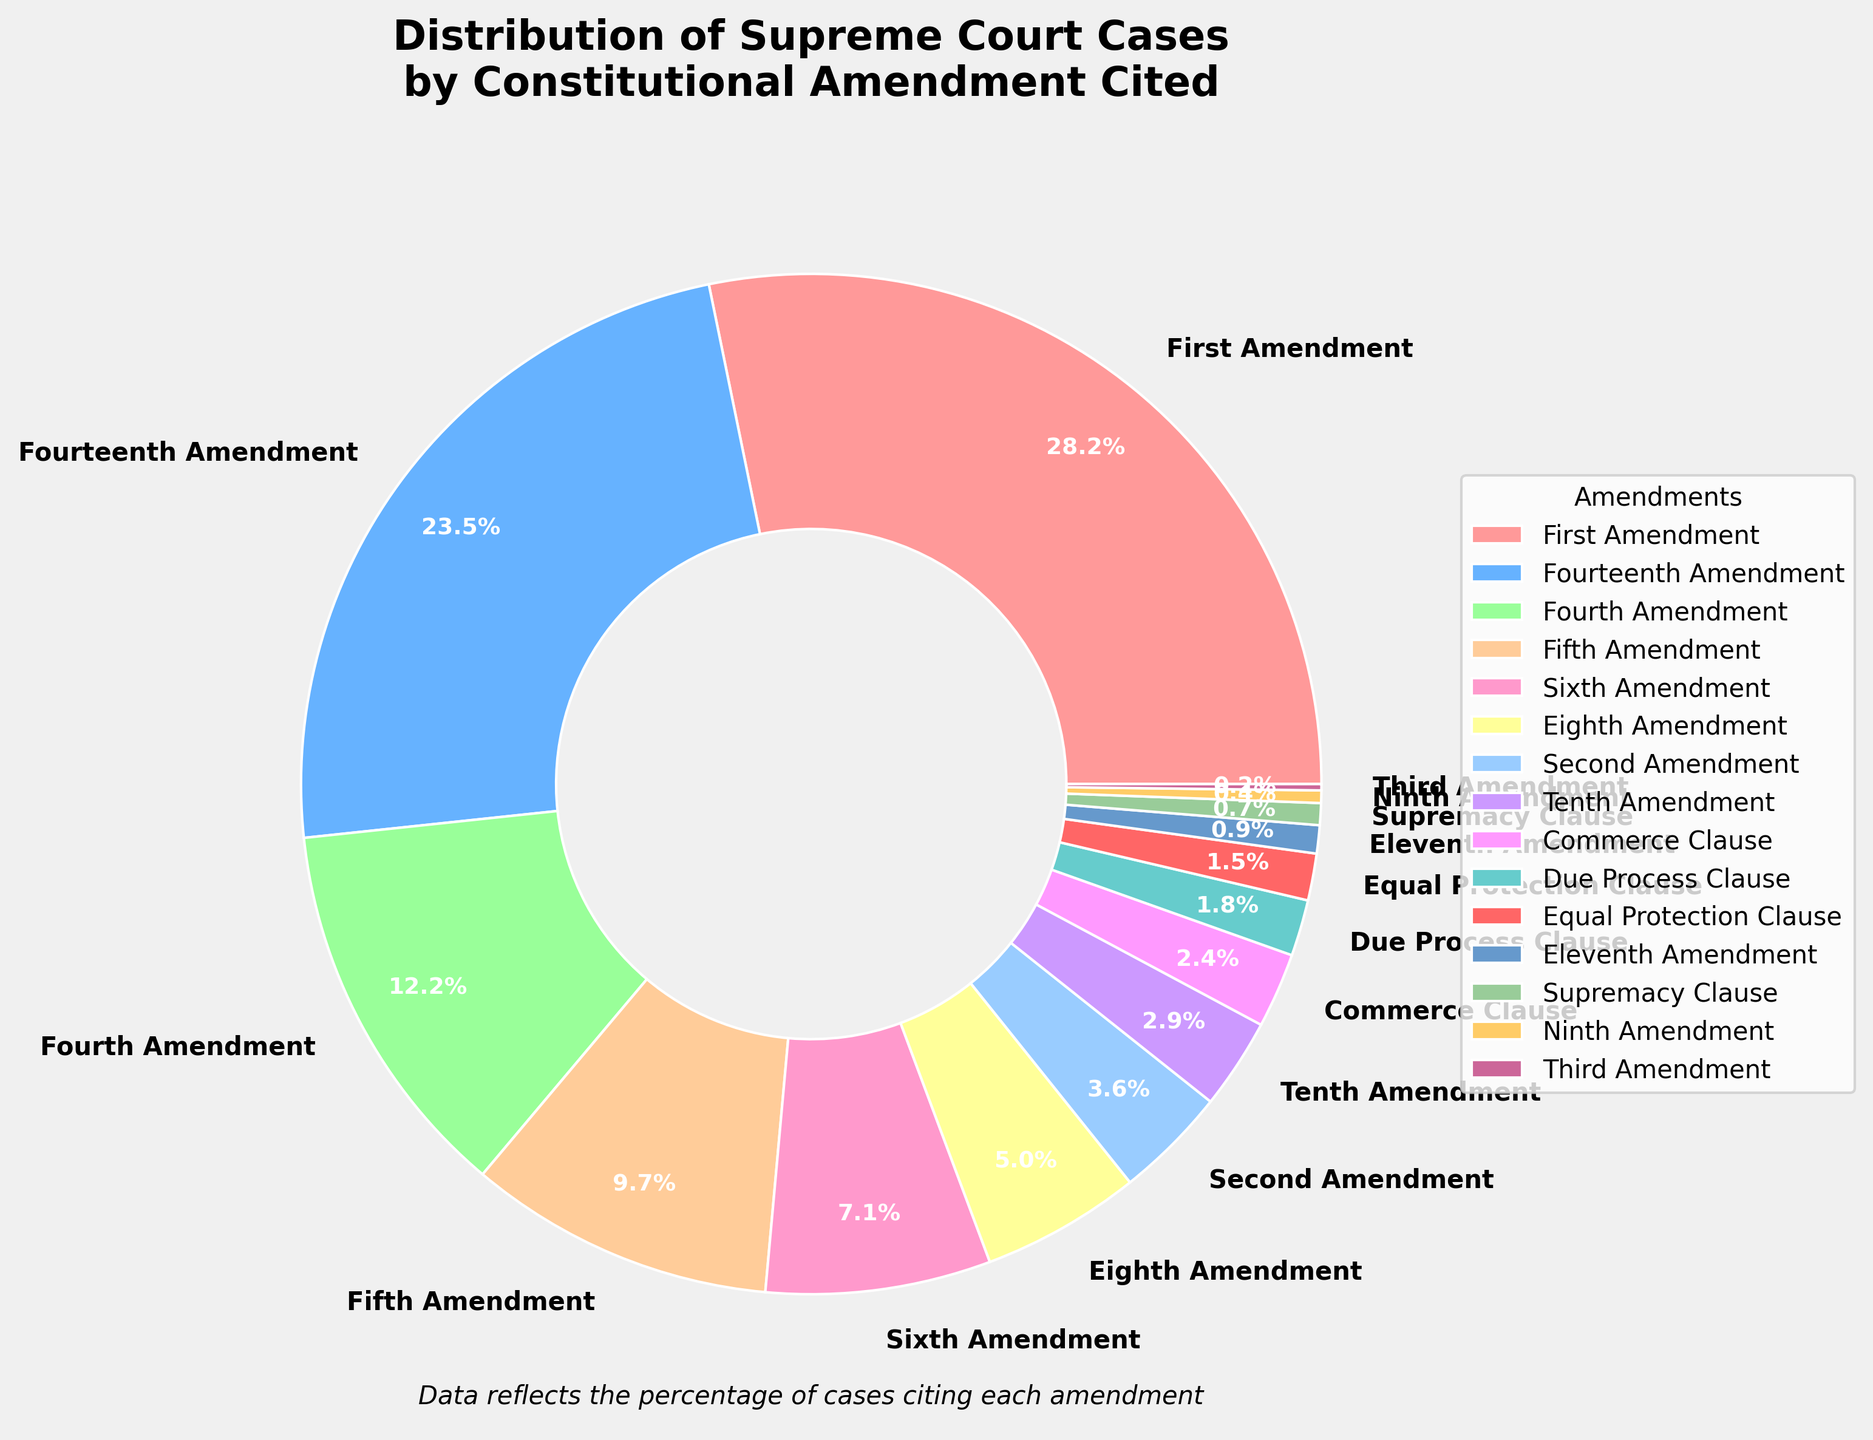Which amendment is cited the most in Supreme Court cases? The largest section of the pie chart represents the amendment cited the most. By visual inspection, 'First Amendment' has the largest portion.
Answer: First Amendment What percentage of cases cite either the Fourth or the Fifth Amendment? Add the percentages for the Fourth Amendment (12.3%) and the Fifth Amendment (9.8%).
Answer: 22.1% Which amendment is cited more frequently: the Commerce Clause or the Due Process Clause? Compare the percentages of Commerce Clause (2.4%) and Due Process Clause (1.8%). The Commerce Clause has a larger portion.
Answer: Commerce Clause Is the percentage of cases citing the Fourteenth Amendment greater than a quarter of the total cases? The Fourteenth Amendment accounts for 23.7% of the cases, which is less than 25% (a quarter) of the total cases.
Answer: No What is the combined percentage for the amendments that individually account for less than 2% of the cases? Sum the percentages for Tenth (2.9%), Commerce Clause (2.4%), Due Process Clause (1.8%), Equal Protection Clause (1.5%), Eleventh (0.9%), Supremacy (0.7%), Ninth (0.4%), and Third (0.2%) Amendments.
Answer: 10.8% How much greater is the percentage of cases citing the First Amendment than those citing the Sixth Amendment? Subtract the percentage for the Sixth Amendment (7.2%) from the First Amendment (28.5%).
Answer: 21.3% Which amendment has the smallest cited percentage, and what is it? Identify the smallest section of the pie chart. The Third Amendment has the smallest percentage at 0.2%.
Answer: Third Amendment, 0.2% Are the cases citing the Fourth and Sixth Amendments together more than those citing the Fourteenth Amendment alone? Add the percentages for the Fourth Amendment (12.3%) and Sixth Amendment (7.2%) and compare the sum with the Fourteenth Amendment (23.7%). The total is 19.5%, which is less.
Answer: No What is the proportion difference between cases citing the Second Amendment and the Tenth Amendment? Subtract the percentage for the Second Amendment (3.6%) from the Tenth Amendment (2.9%). The difference is 0.7%.
Answer: 0.7% Is the percentage of cases citing the Eighth Amendment closer to that of the Fourth Amendment or the Sixth Amendment? Compare the differences between the Eighth Amendment (5.1%) and both the Fourth Amendment (12.3%) and Sixth Amendment (7.2%). The difference is smaller with the Sixth Amendment (5.1% - 7.2% = -2.1%) than with the Fourth Amendment (5.1% - 12.3% = -7.2%).
Answer: Sixth Amendment 